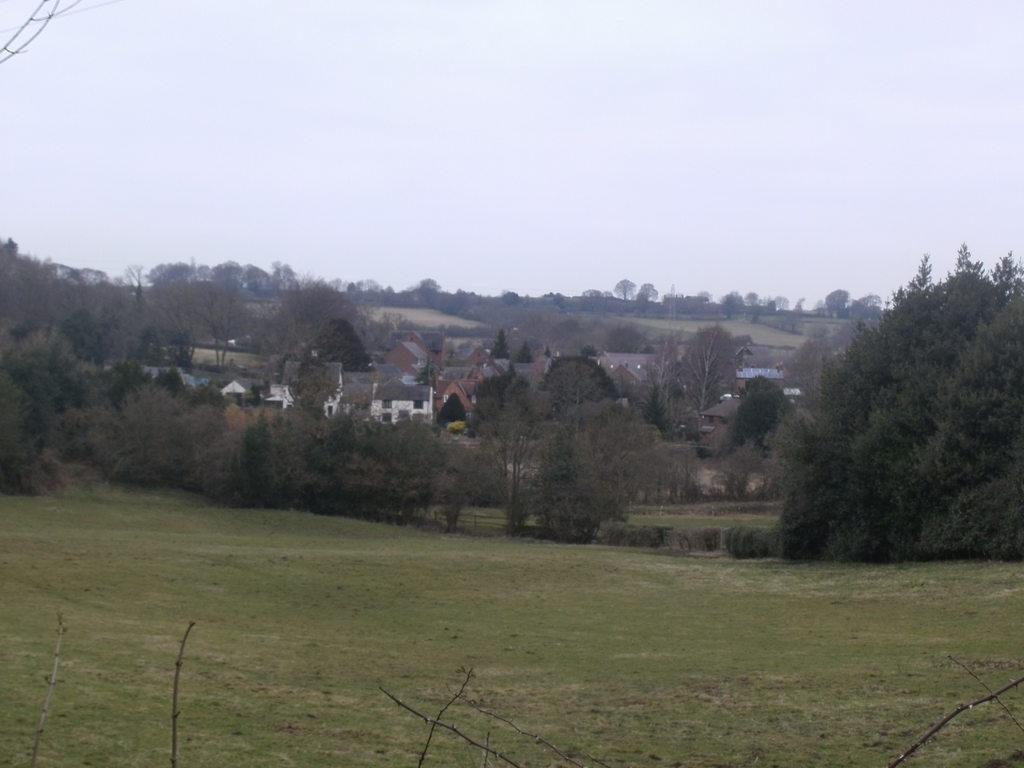What type of structures can be seen in the image? There are buildings in the image. What type of vegetation is present in the image? There are trees in the image. What is visible at the top of the image? The sky is visible at the top of the image. What type of ground surface is present at the bottom of the image? Grass is present at the bottom of the image. What part of the trees is visible in the foreground of the image? Tree branches are visible in the foreground of the image. What type of plate is hanging from the tree branches in the image? There is no plate present in the image; only buildings, trees, sky, grass, and tree branches are visible. 